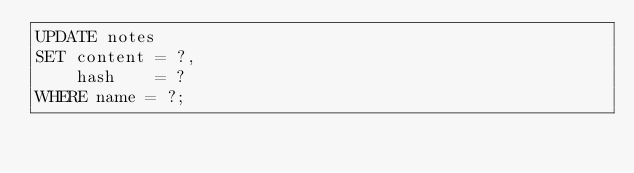<code> <loc_0><loc_0><loc_500><loc_500><_SQL_>UPDATE notes
SET content = ?,
    hash    = ?
WHERE name = ?;</code> 